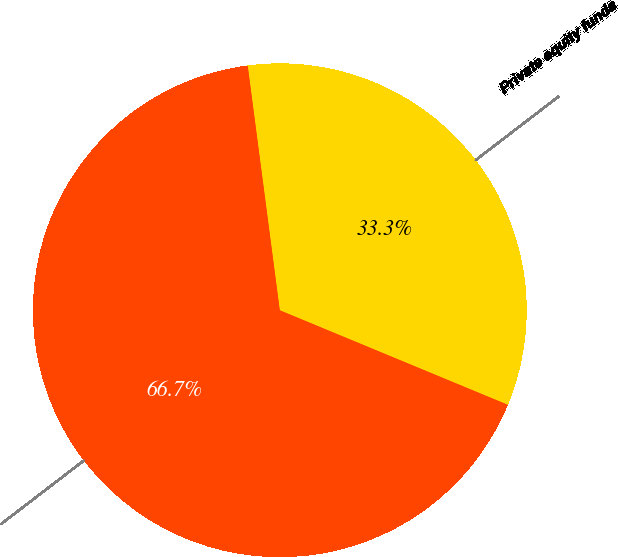Convert chart. <chart><loc_0><loc_0><loc_500><loc_500><pie_chart><fcel>Private equity funds<fcel>Total<nl><fcel>33.33%<fcel>66.67%<nl></chart> 